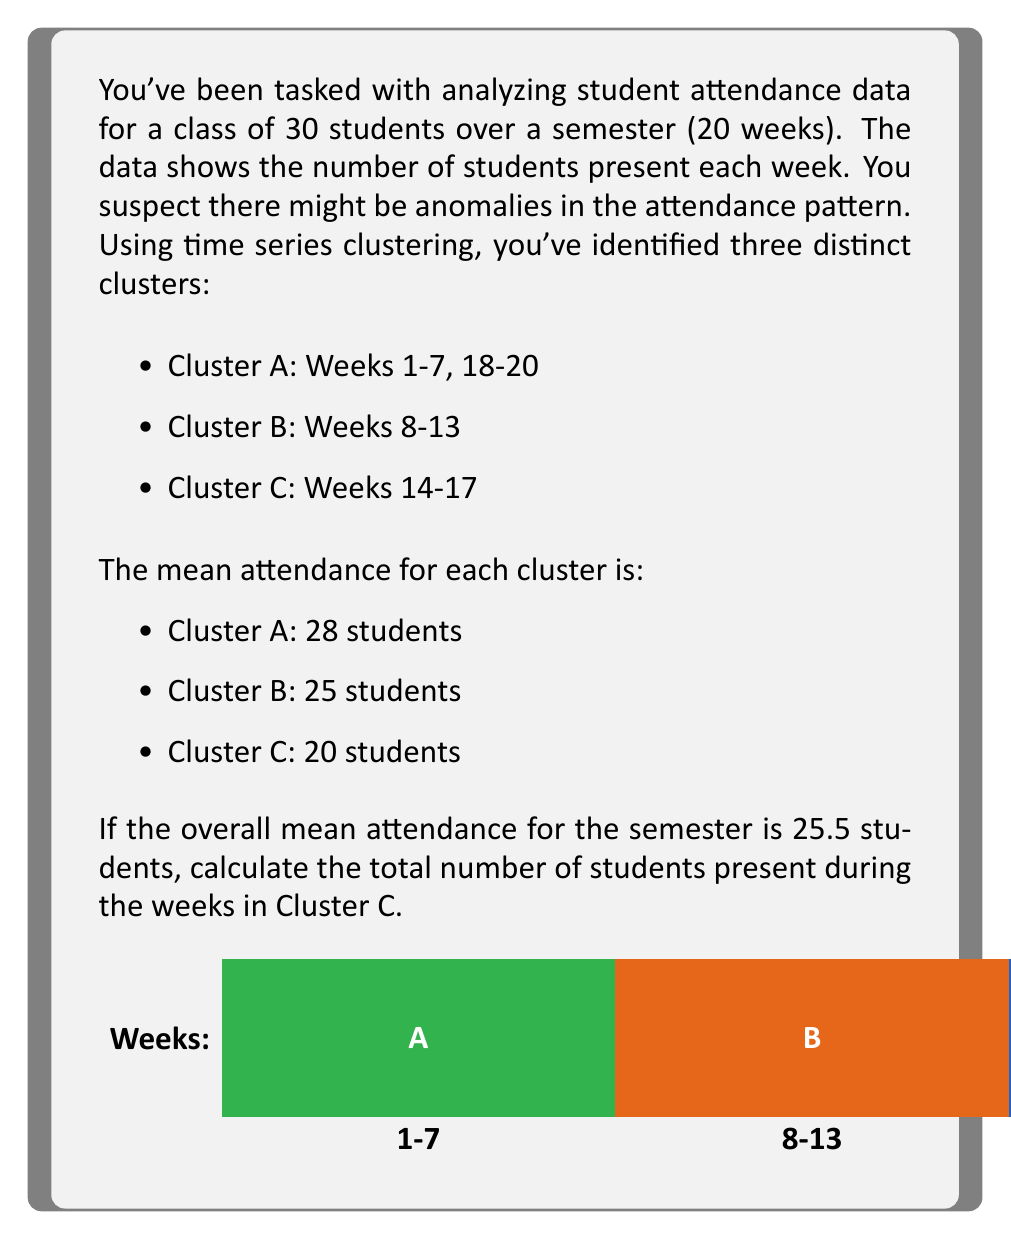Show me your answer to this math problem. Let's approach this step-by-step:

1) First, let's identify how many weeks are in each cluster:
   Cluster A: 7 + 3 = 10 weeks
   Cluster B: 6 weeks
   Cluster C: 4 weeks
   Total: 20 weeks (which matches our semester length)

2) Now, let's set up an equation using the overall mean:
   $$ \frac{(28 \times 10) + (25 \times 6) + (20 \times 4)}{20} = 25.5 $$

3) Let's simplify the left side:
   $$ \frac{280 + 150 + 80}{20} = 25.5 $$

4) Multiply both sides by 20:
   $$ 280 + 150 + 80 = 510 $$

5) This confirms our calculation is correct, as the total matches the overall mean multiplied by the number of weeks (25.5 × 20 = 510).

6) To find the total number of students present during Cluster C, we multiply the mean of Cluster C by the number of weeks in Cluster C:
   $$ 20 \times 4 = 80 $$

Therefore, the total number of students present during the weeks in Cluster C is 80.
Answer: 80 students 